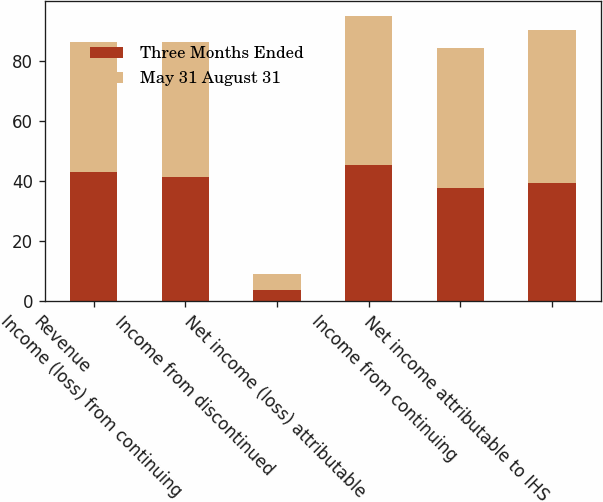Convert chart to OTSL. <chart><loc_0><loc_0><loc_500><loc_500><stacked_bar_chart><ecel><fcel>Revenue<fcel>Income (loss) from continuing<fcel>Income from discontinued<fcel>Net income (loss) attributable<fcel>Income from continuing<fcel>Net income attributable to IHS<nl><fcel>Three Months Ended<fcel>43.1<fcel>41.4<fcel>3.8<fcel>45.2<fcel>37.7<fcel>39.4<nl><fcel>May 31 August 31<fcel>43.1<fcel>44.8<fcel>5.2<fcel>50<fcel>46.8<fcel>51<nl></chart> 